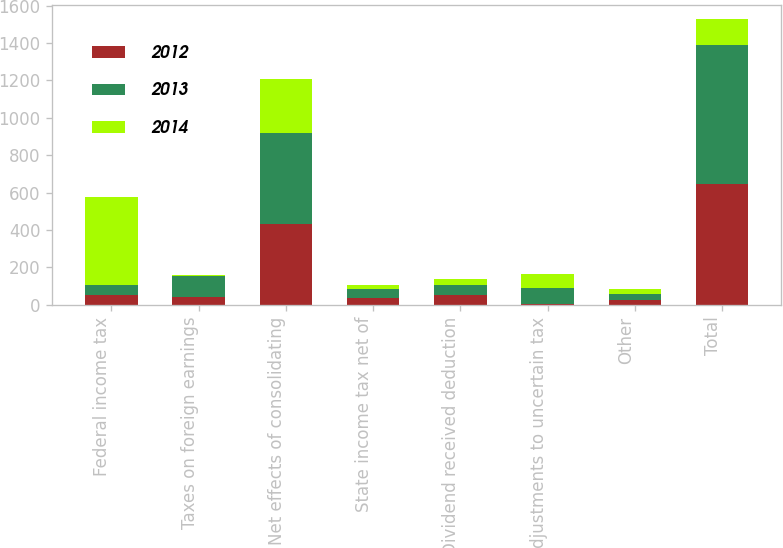Convert chart. <chart><loc_0><loc_0><loc_500><loc_500><stacked_bar_chart><ecel><fcel>Federal income tax<fcel>Taxes on foreign earnings<fcel>Net effects of consolidating<fcel>State income tax net of<fcel>Dividend received deduction<fcel>Adjustments to uncertain tax<fcel>Other<fcel>Total<nl><fcel>2012<fcel>52<fcel>40<fcel>433<fcel>37<fcel>50<fcel>5<fcel>28<fcel>648<nl><fcel>2013<fcel>52<fcel>112<fcel>488<fcel>45<fcel>54<fcel>87<fcel>32<fcel>742<nl><fcel>2014<fcel>470<fcel>6<fcel>288<fcel>21<fcel>32<fcel>72<fcel>26<fcel>139<nl></chart> 